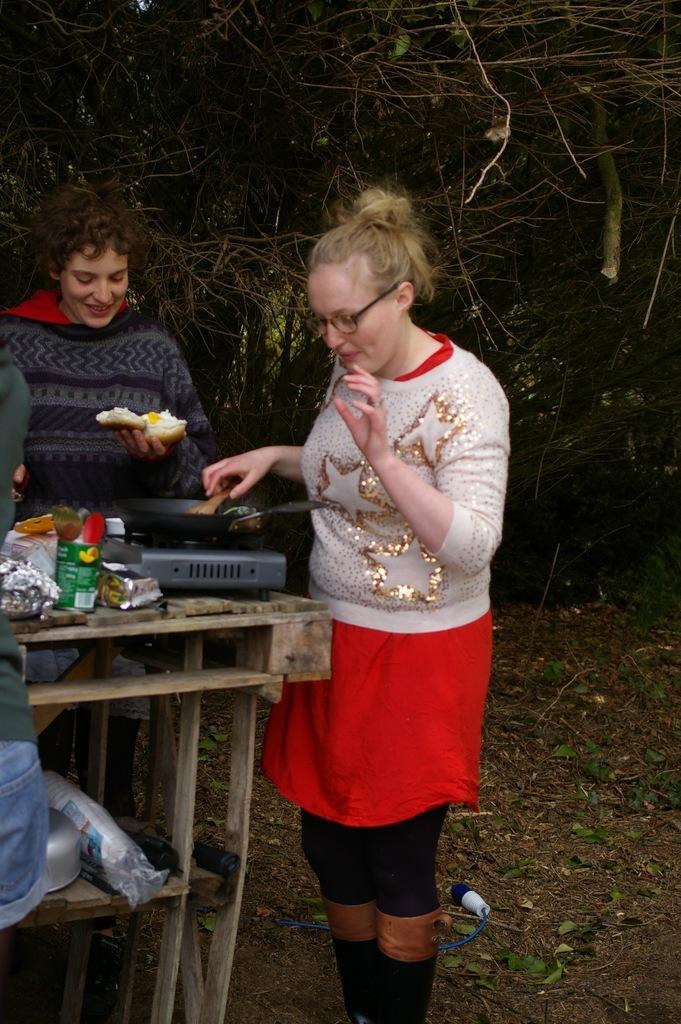Could you give a brief overview of what you see in this image? In this picture I can see a woman standing and holding a wooden serving spoon and I can see another woman holding some food in her hand and I can see few packets on the wooden table and I can see a vessel and another man standing on the side and looks like a stove on the table and I can see a pan on the stove and I can see few trees and looks like a rope on the ground. 